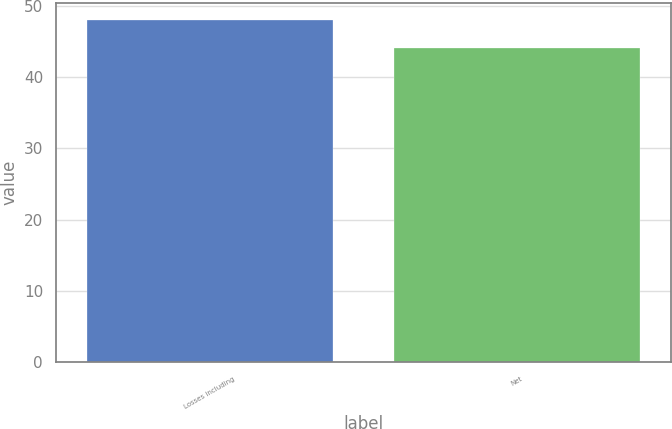Convert chart to OTSL. <chart><loc_0><loc_0><loc_500><loc_500><bar_chart><fcel>Losses including<fcel>Net<nl><fcel>48<fcel>44<nl></chart> 